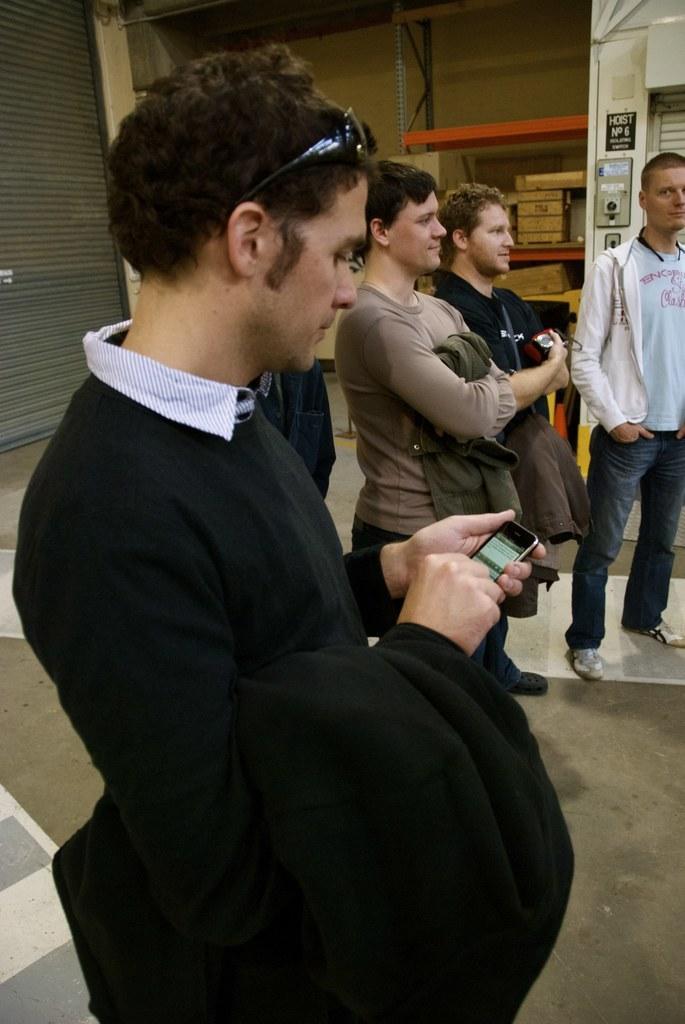Please provide a concise description of this image. In the center of the image we can see person standing and holding a mobile phone. In the background we can see persons, wall, switch board and objects placed on the racks. 